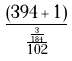Convert formula to latex. <formula><loc_0><loc_0><loc_500><loc_500>\frac { ( 3 9 4 + 1 ) } { \frac { \frac { 3 } { 1 8 4 } } { 1 0 2 } }</formula> 